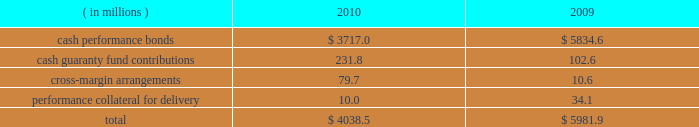Anticipated or possible short-term cash needs , prevailing interest rates , our investment policy and alternative investment choices .
A majority of our cash and cash equivalents balance is invested in money market mutual funds that invest only in u.s .
Treasury securities or u.s .
Government agency securities .
Our exposure to risk is minimal given the nature of the investments .
Our practice is to have our pension plan 100% ( 100 % ) funded at each year end on a projected benefit obligation basis , while also satisfying any minimum required contribution and obtaining the maximum tax deduction .
Based on our actuarial projections , we estimate that a $ 14.1 million contribution in 2011 will allow us to meet our funding goal .
However , the amount of the actual contribution is contingent on the actual rate of return on our plan assets during 2011 and the december 31 , 2011 discount rate .
Net current deferred tax assets of $ 18.3 million and $ 23.8 million are included in other current assets at december 31 , 2010 and 2009 , respectively .
Total net current deferred tax assets include unrealized losses , stock- based compensation and accrued expenses .
Net long-term deferred tax liabilities were $ 7.8 billion and $ 7.6 billion at december 31 , 2010 and 2009 , respectively .
Net deferred tax liabilities are principally the result of purchase accounting for intangible assets in our various mergers including cbot holdings and nymex holdings .
We have a long-term deferred tax asset of $ 145.7 million included within our domestic long-term deferred tax liability .
This deferred tax asset is for an unrealized capital loss incurred in brazil related to our investment in bm&fbovespa .
As of december 31 , 2010 , we do not believe that we currently meet the more-likely-than-not threshold that would allow us to fully realize the value of the unrealized capital loss .
As a result , a partial valuation allowance of $ 64.4 million has been provided for the amount of the unrealized capital loss that exceeds potential capital gains that could be used to offset the capital loss in future periods .
We also have a long-term deferred tax asset related to brazilian taxes of $ 125.3 million for an unrealized capital loss incurred in brazil related to our investment in bm&fbovespa .
A full valuation allowance of $ 125.3 million has been provided because we do not believe that we currently meet the more-likely-than-not threshold that would allow us to realize the value of the unrealized capital loss in brazil in the future .
Valuation allowances of $ 49.4 million have also been provided for additional unrealized capital losses on various other investments .
Net long-term deferred tax assets also include a $ 19.3 million deferred tax asset for foreign net operating losses related to swapstream .
Our assessment at december 31 , 2010 was that we did not currently meet the more-likely- than-not threshold that would allow us to realize the value of acquired and accumulated foreign net operating losses in the future .
As a result , the $ 19.3 million deferred tax assets arising from these net operating losses have been fully reserved .
Each clearing firm is required to deposit and maintain specified performance bond collateral .
Performance bond requirements are determined by parameters established by the risk management department of the clearing house and may fluctuate over time .
We accept a variety of collateral to satisfy performance bond requirements .
Cash performance bonds and guaranty fund contributions are included in our consolidated balance sheets .
Clearing firm deposits , other than those retained in the form of cash , are not included in our consolidated balance sheets .
The balances in cash performance bonds and guaranty fund contributions may fluctuate significantly over time .
Cash performance bonds and guaranty fund contributions consisted of the following at december 31: .

What is the percentual amount represented by cash performance bonds and cash guaranty fund contributions in the total figure of 2010 , in millions? 
Rationale: its the sum of the cash performance bonds and cash guaranty fund contributions divided by the total of 2010 .
Computations: ((3717.0 + 231.8) / 4038.5)
Answer: 0.97779. 